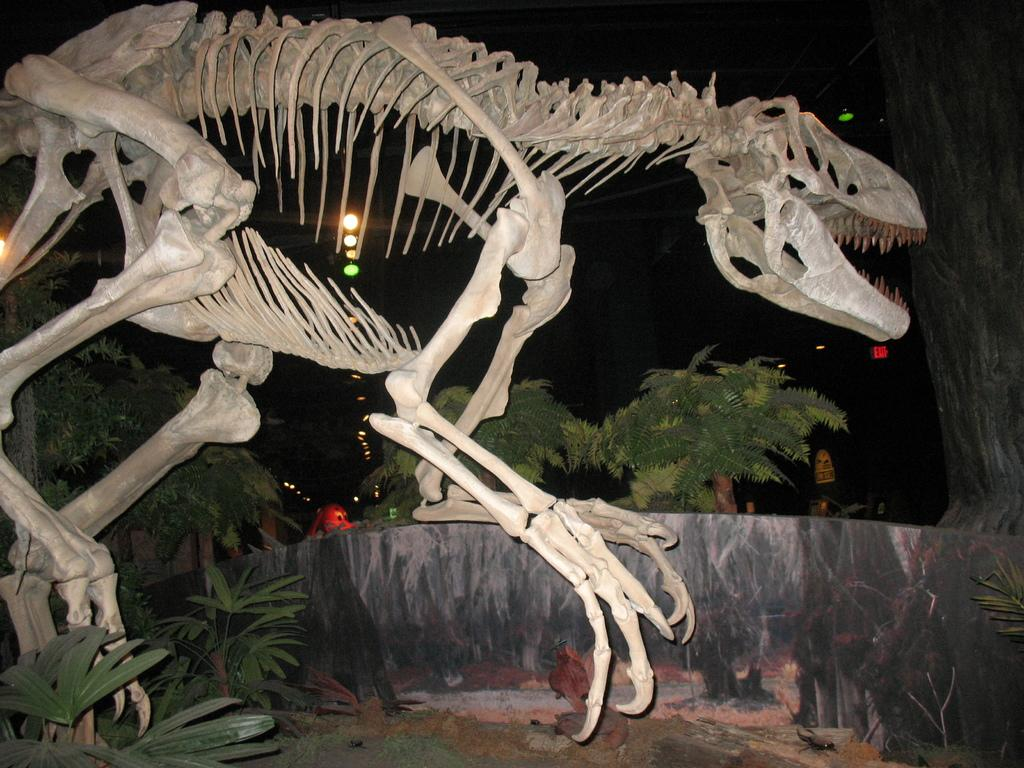What is the main subject of the picture? The main subject of the picture is a skeleton. What can be seen in the background of the picture? In the background of the picture, there are plants, trees, and lights. Who is the creator of the stick that the skeleton is holding in the image? There is no stick present in the image, and therefore no creator can be identified. 